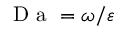Convert formula to latex. <formula><loc_0><loc_0><loc_500><loc_500>D a = \omega / \varepsilon</formula> 